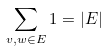<formula> <loc_0><loc_0><loc_500><loc_500>\sum _ { v , w \in E } 1 = | E |</formula> 